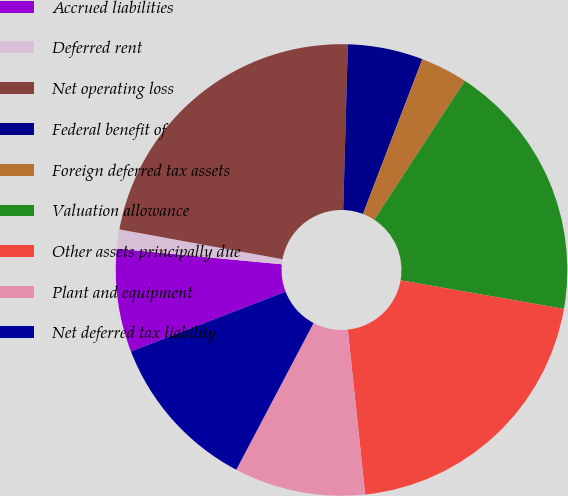Convert chart to OTSL. <chart><loc_0><loc_0><loc_500><loc_500><pie_chart><fcel>Accrued liabilities<fcel>Deferred rent<fcel>Net operating loss<fcel>Federal benefit of<fcel>Foreign deferred tax assets<fcel>Valuation allowance<fcel>Other assets principally due<fcel>Plant and equipment<fcel>Net deferred tax liability<nl><fcel>7.39%<fcel>1.37%<fcel>22.57%<fcel>5.38%<fcel>3.37%<fcel>18.56%<fcel>20.57%<fcel>9.39%<fcel>11.4%<nl></chart> 